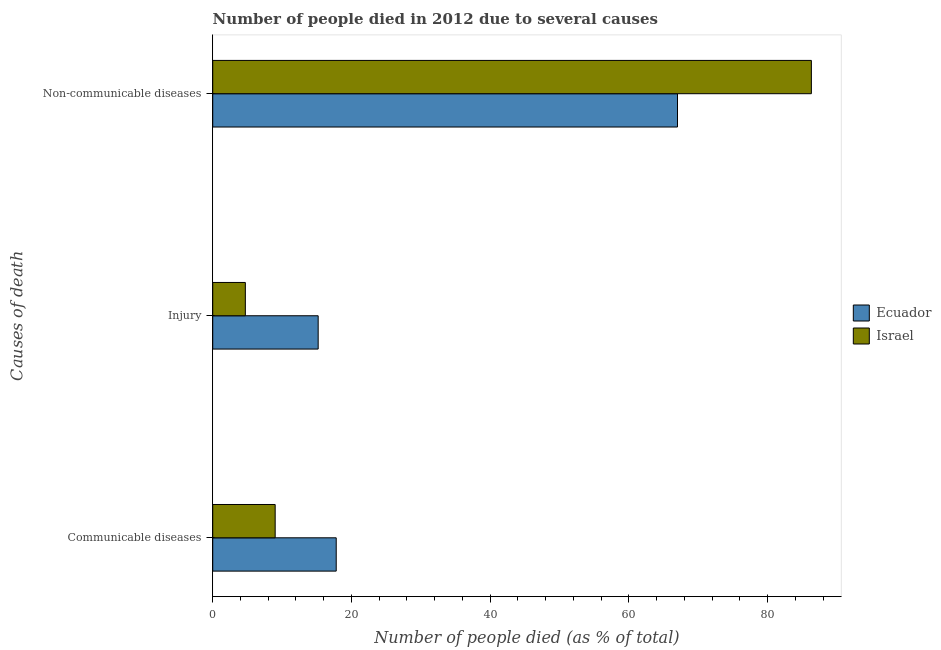How many different coloured bars are there?
Ensure brevity in your answer.  2. How many groups of bars are there?
Offer a very short reply. 3. How many bars are there on the 3rd tick from the bottom?
Give a very brief answer. 2. What is the label of the 2nd group of bars from the top?
Offer a very short reply. Injury. What is the number of people who died of communicable diseases in Ecuador?
Offer a terse response. 17.8. Across all countries, what is the maximum number of people who died of injury?
Your response must be concise. 15.2. In which country was the number of people who dies of non-communicable diseases maximum?
Offer a terse response. Israel. In which country was the number of people who dies of non-communicable diseases minimum?
Offer a terse response. Ecuador. What is the total number of people who died of communicable diseases in the graph?
Give a very brief answer. 26.8. What is the average number of people who died of injury per country?
Your response must be concise. 9.95. What is the difference between the number of people who died of communicable diseases and number of people who died of injury in Ecuador?
Provide a succinct answer. 2.6. What is the ratio of the number of people who dies of non-communicable diseases in Israel to that in Ecuador?
Provide a succinct answer. 1.29. Is the number of people who died of injury in Ecuador less than that in Israel?
Provide a short and direct response. No. What is the difference between the highest and the second highest number of people who dies of non-communicable diseases?
Provide a short and direct response. 19.3. What is the difference between the highest and the lowest number of people who died of injury?
Your answer should be very brief. 10.5. In how many countries, is the number of people who dies of non-communicable diseases greater than the average number of people who dies of non-communicable diseases taken over all countries?
Offer a terse response. 1. Is the sum of the number of people who dies of non-communicable diseases in Ecuador and Israel greater than the maximum number of people who died of injury across all countries?
Offer a very short reply. Yes. What does the 1st bar from the top in Non-communicable diseases represents?
Keep it short and to the point. Israel. What does the 1st bar from the bottom in Non-communicable diseases represents?
Your answer should be compact. Ecuador. Is it the case that in every country, the sum of the number of people who died of communicable diseases and number of people who died of injury is greater than the number of people who dies of non-communicable diseases?
Your answer should be compact. No. What is the difference between two consecutive major ticks on the X-axis?
Provide a succinct answer. 20. Are the values on the major ticks of X-axis written in scientific E-notation?
Make the answer very short. No. Does the graph contain any zero values?
Offer a very short reply. No. What is the title of the graph?
Your response must be concise. Number of people died in 2012 due to several causes. Does "Afghanistan" appear as one of the legend labels in the graph?
Your answer should be compact. No. What is the label or title of the X-axis?
Provide a short and direct response. Number of people died (as % of total). What is the label or title of the Y-axis?
Your response must be concise. Causes of death. What is the Number of people died (as % of total) of Ecuador in Non-communicable diseases?
Give a very brief answer. 67. What is the Number of people died (as % of total) in Israel in Non-communicable diseases?
Your answer should be compact. 86.3. Across all Causes of death, what is the maximum Number of people died (as % of total) of Ecuador?
Keep it short and to the point. 67. Across all Causes of death, what is the maximum Number of people died (as % of total) of Israel?
Offer a terse response. 86.3. Across all Causes of death, what is the minimum Number of people died (as % of total) in Ecuador?
Provide a succinct answer. 15.2. What is the total Number of people died (as % of total) in Ecuador in the graph?
Ensure brevity in your answer.  100. What is the total Number of people died (as % of total) of Israel in the graph?
Keep it short and to the point. 100. What is the difference between the Number of people died (as % of total) in Ecuador in Communicable diseases and that in Injury?
Provide a short and direct response. 2.6. What is the difference between the Number of people died (as % of total) of Israel in Communicable diseases and that in Injury?
Make the answer very short. 4.3. What is the difference between the Number of people died (as % of total) of Ecuador in Communicable diseases and that in Non-communicable diseases?
Offer a terse response. -49.2. What is the difference between the Number of people died (as % of total) in Israel in Communicable diseases and that in Non-communicable diseases?
Offer a very short reply. -77.3. What is the difference between the Number of people died (as % of total) of Ecuador in Injury and that in Non-communicable diseases?
Your answer should be compact. -51.8. What is the difference between the Number of people died (as % of total) of Israel in Injury and that in Non-communicable diseases?
Provide a succinct answer. -81.6. What is the difference between the Number of people died (as % of total) in Ecuador in Communicable diseases and the Number of people died (as % of total) in Israel in Non-communicable diseases?
Offer a terse response. -68.5. What is the difference between the Number of people died (as % of total) of Ecuador in Injury and the Number of people died (as % of total) of Israel in Non-communicable diseases?
Offer a terse response. -71.1. What is the average Number of people died (as % of total) of Ecuador per Causes of death?
Ensure brevity in your answer.  33.33. What is the average Number of people died (as % of total) in Israel per Causes of death?
Give a very brief answer. 33.33. What is the difference between the Number of people died (as % of total) of Ecuador and Number of people died (as % of total) of Israel in Communicable diseases?
Provide a short and direct response. 8.8. What is the difference between the Number of people died (as % of total) in Ecuador and Number of people died (as % of total) in Israel in Injury?
Provide a short and direct response. 10.5. What is the difference between the Number of people died (as % of total) of Ecuador and Number of people died (as % of total) of Israel in Non-communicable diseases?
Your answer should be very brief. -19.3. What is the ratio of the Number of people died (as % of total) of Ecuador in Communicable diseases to that in Injury?
Offer a very short reply. 1.17. What is the ratio of the Number of people died (as % of total) in Israel in Communicable diseases to that in Injury?
Provide a succinct answer. 1.91. What is the ratio of the Number of people died (as % of total) of Ecuador in Communicable diseases to that in Non-communicable diseases?
Ensure brevity in your answer.  0.27. What is the ratio of the Number of people died (as % of total) in Israel in Communicable diseases to that in Non-communicable diseases?
Your answer should be very brief. 0.1. What is the ratio of the Number of people died (as % of total) of Ecuador in Injury to that in Non-communicable diseases?
Give a very brief answer. 0.23. What is the ratio of the Number of people died (as % of total) in Israel in Injury to that in Non-communicable diseases?
Your response must be concise. 0.05. What is the difference between the highest and the second highest Number of people died (as % of total) in Ecuador?
Offer a very short reply. 49.2. What is the difference between the highest and the second highest Number of people died (as % of total) in Israel?
Offer a very short reply. 77.3. What is the difference between the highest and the lowest Number of people died (as % of total) in Ecuador?
Offer a terse response. 51.8. What is the difference between the highest and the lowest Number of people died (as % of total) of Israel?
Keep it short and to the point. 81.6. 